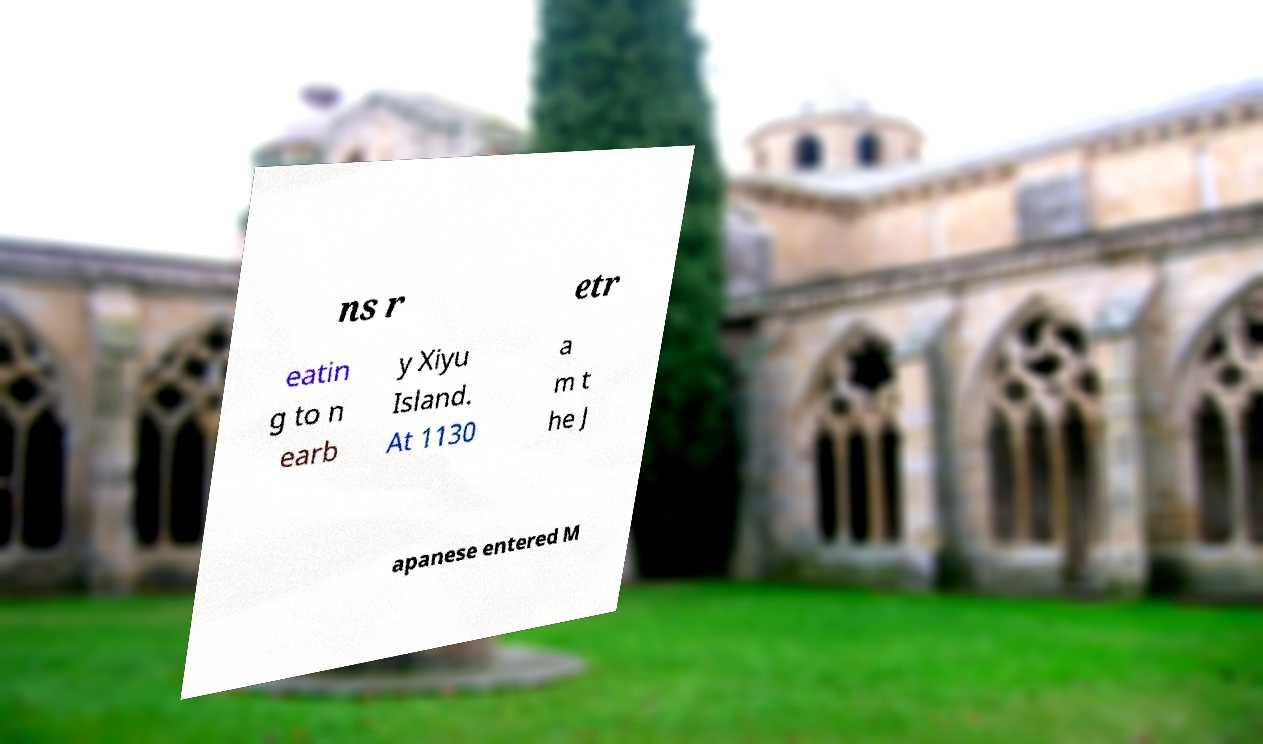Can you accurately transcribe the text from the provided image for me? ns r etr eatin g to n earb y Xiyu Island. At 1130 a m t he J apanese entered M 